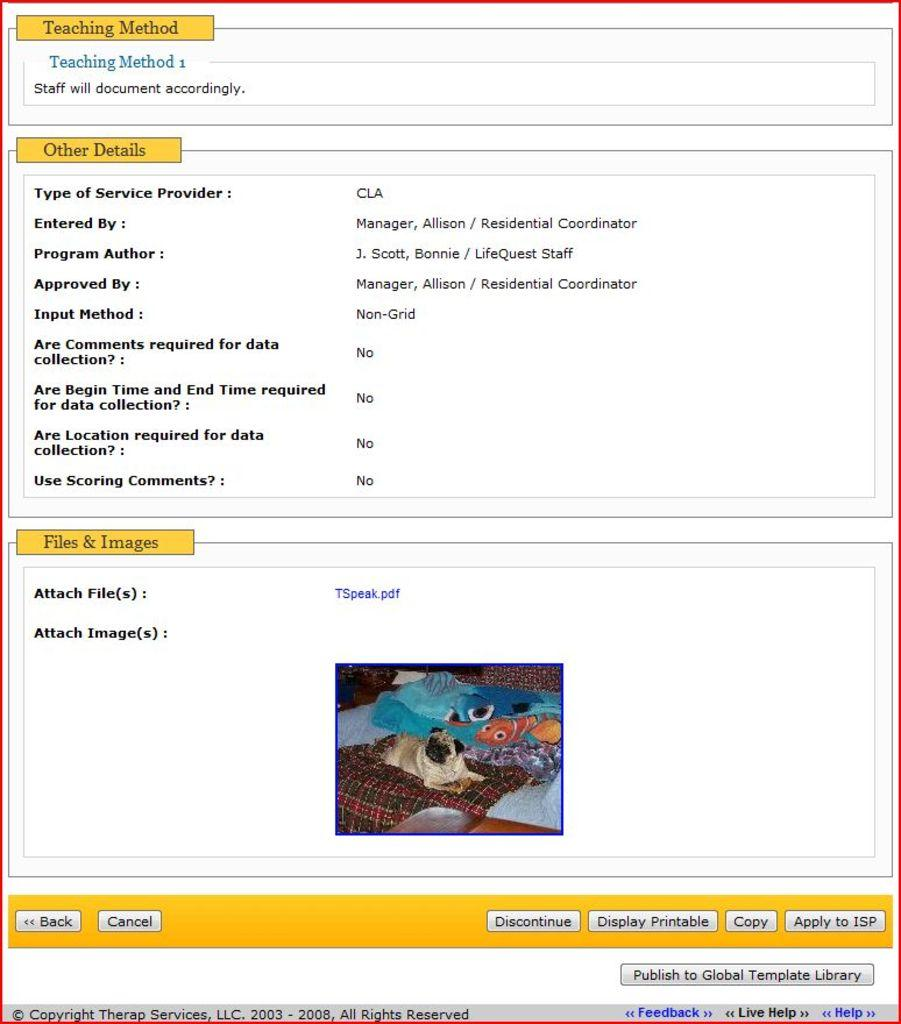What is the main component of the image? The image is a screen. What can be seen on the screen besides the image? There are texts on the screen. What type of image is displayed on the screen? There is an image on the screen. What is the color of the background on the screen? The background of the screen is white in color. How many dinosaurs are visible in the image? There are no dinosaurs present in the image; it is a screen with texts and an image on a white background. What type of cart is shown in the image? There is no cart present in the image. 